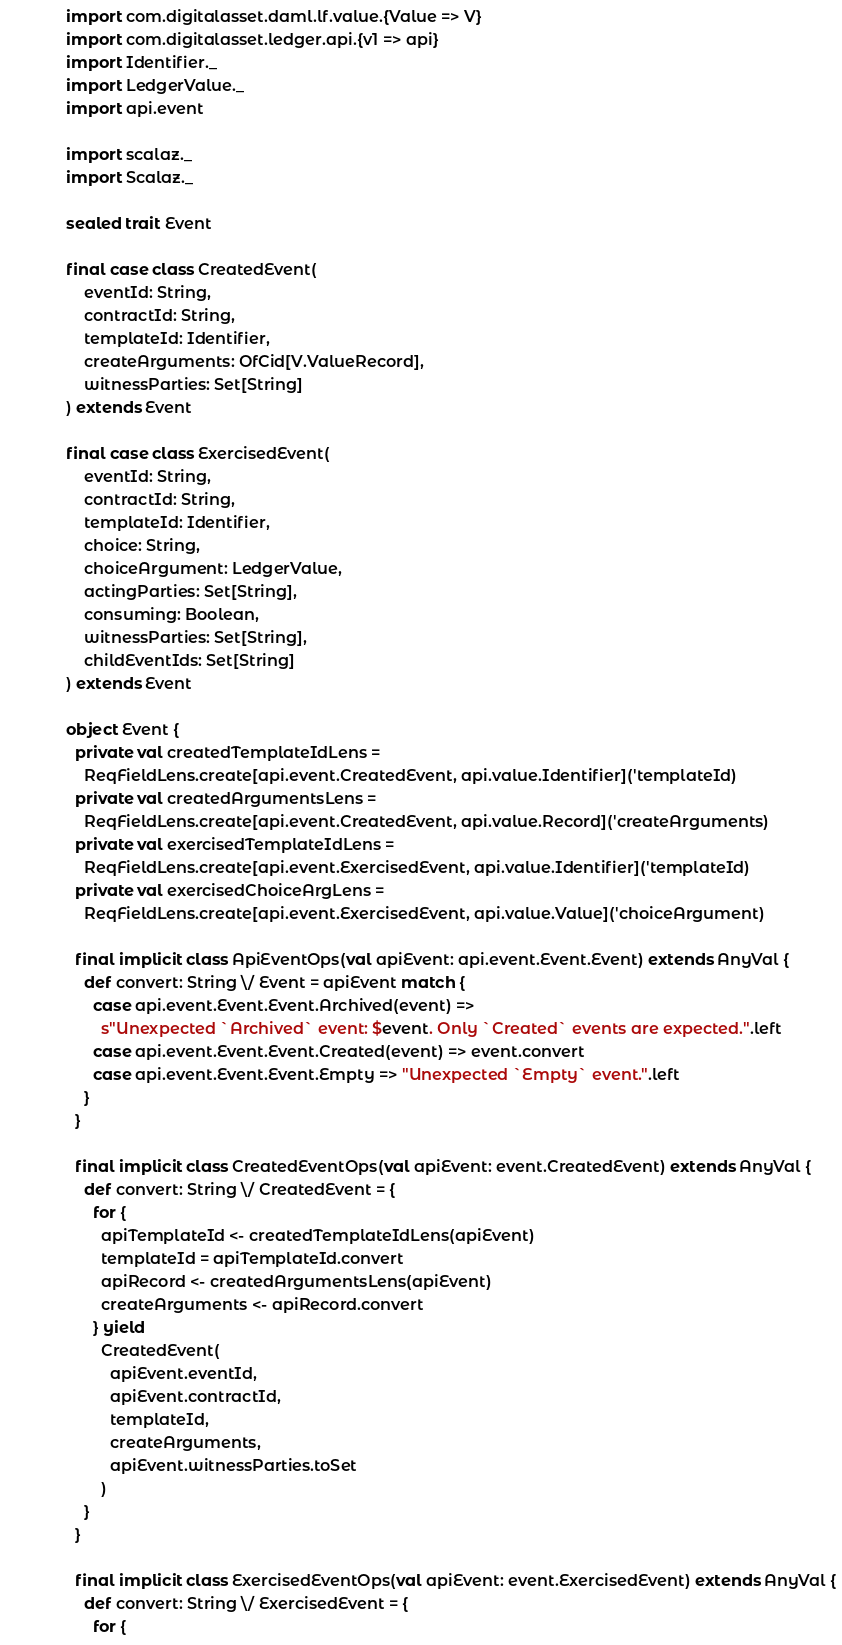Convert code to text. <code><loc_0><loc_0><loc_500><loc_500><_Scala_>
import com.digitalasset.daml.lf.value.{Value => V}
import com.digitalasset.ledger.api.{v1 => api}
import Identifier._
import LedgerValue._
import api.event

import scalaz._
import Scalaz._

sealed trait Event

final case class CreatedEvent(
    eventId: String,
    contractId: String,
    templateId: Identifier,
    createArguments: OfCid[V.ValueRecord],
    witnessParties: Set[String]
) extends Event

final case class ExercisedEvent(
    eventId: String,
    contractId: String,
    templateId: Identifier,
    choice: String,
    choiceArgument: LedgerValue,
    actingParties: Set[String],
    consuming: Boolean,
    witnessParties: Set[String],
    childEventIds: Set[String]
) extends Event

object Event {
  private val createdTemplateIdLens =
    ReqFieldLens.create[api.event.CreatedEvent, api.value.Identifier]('templateId)
  private val createdArgumentsLens =
    ReqFieldLens.create[api.event.CreatedEvent, api.value.Record]('createArguments)
  private val exercisedTemplateIdLens =
    ReqFieldLens.create[api.event.ExercisedEvent, api.value.Identifier]('templateId)
  private val exercisedChoiceArgLens =
    ReqFieldLens.create[api.event.ExercisedEvent, api.value.Value]('choiceArgument)

  final implicit class ApiEventOps(val apiEvent: api.event.Event.Event) extends AnyVal {
    def convert: String \/ Event = apiEvent match {
      case api.event.Event.Event.Archived(event) =>
        s"Unexpected `Archived` event: $event. Only `Created` events are expected.".left
      case api.event.Event.Event.Created(event) => event.convert
      case api.event.Event.Event.Empty => "Unexpected `Empty` event.".left
    }
  }

  final implicit class CreatedEventOps(val apiEvent: event.CreatedEvent) extends AnyVal {
    def convert: String \/ CreatedEvent = {
      for {
        apiTemplateId <- createdTemplateIdLens(apiEvent)
        templateId = apiTemplateId.convert
        apiRecord <- createdArgumentsLens(apiEvent)
        createArguments <- apiRecord.convert
      } yield
        CreatedEvent(
          apiEvent.eventId,
          apiEvent.contractId,
          templateId,
          createArguments,
          apiEvent.witnessParties.toSet
        )
    }
  }

  final implicit class ExercisedEventOps(val apiEvent: event.ExercisedEvent) extends AnyVal {
    def convert: String \/ ExercisedEvent = {
      for {</code> 